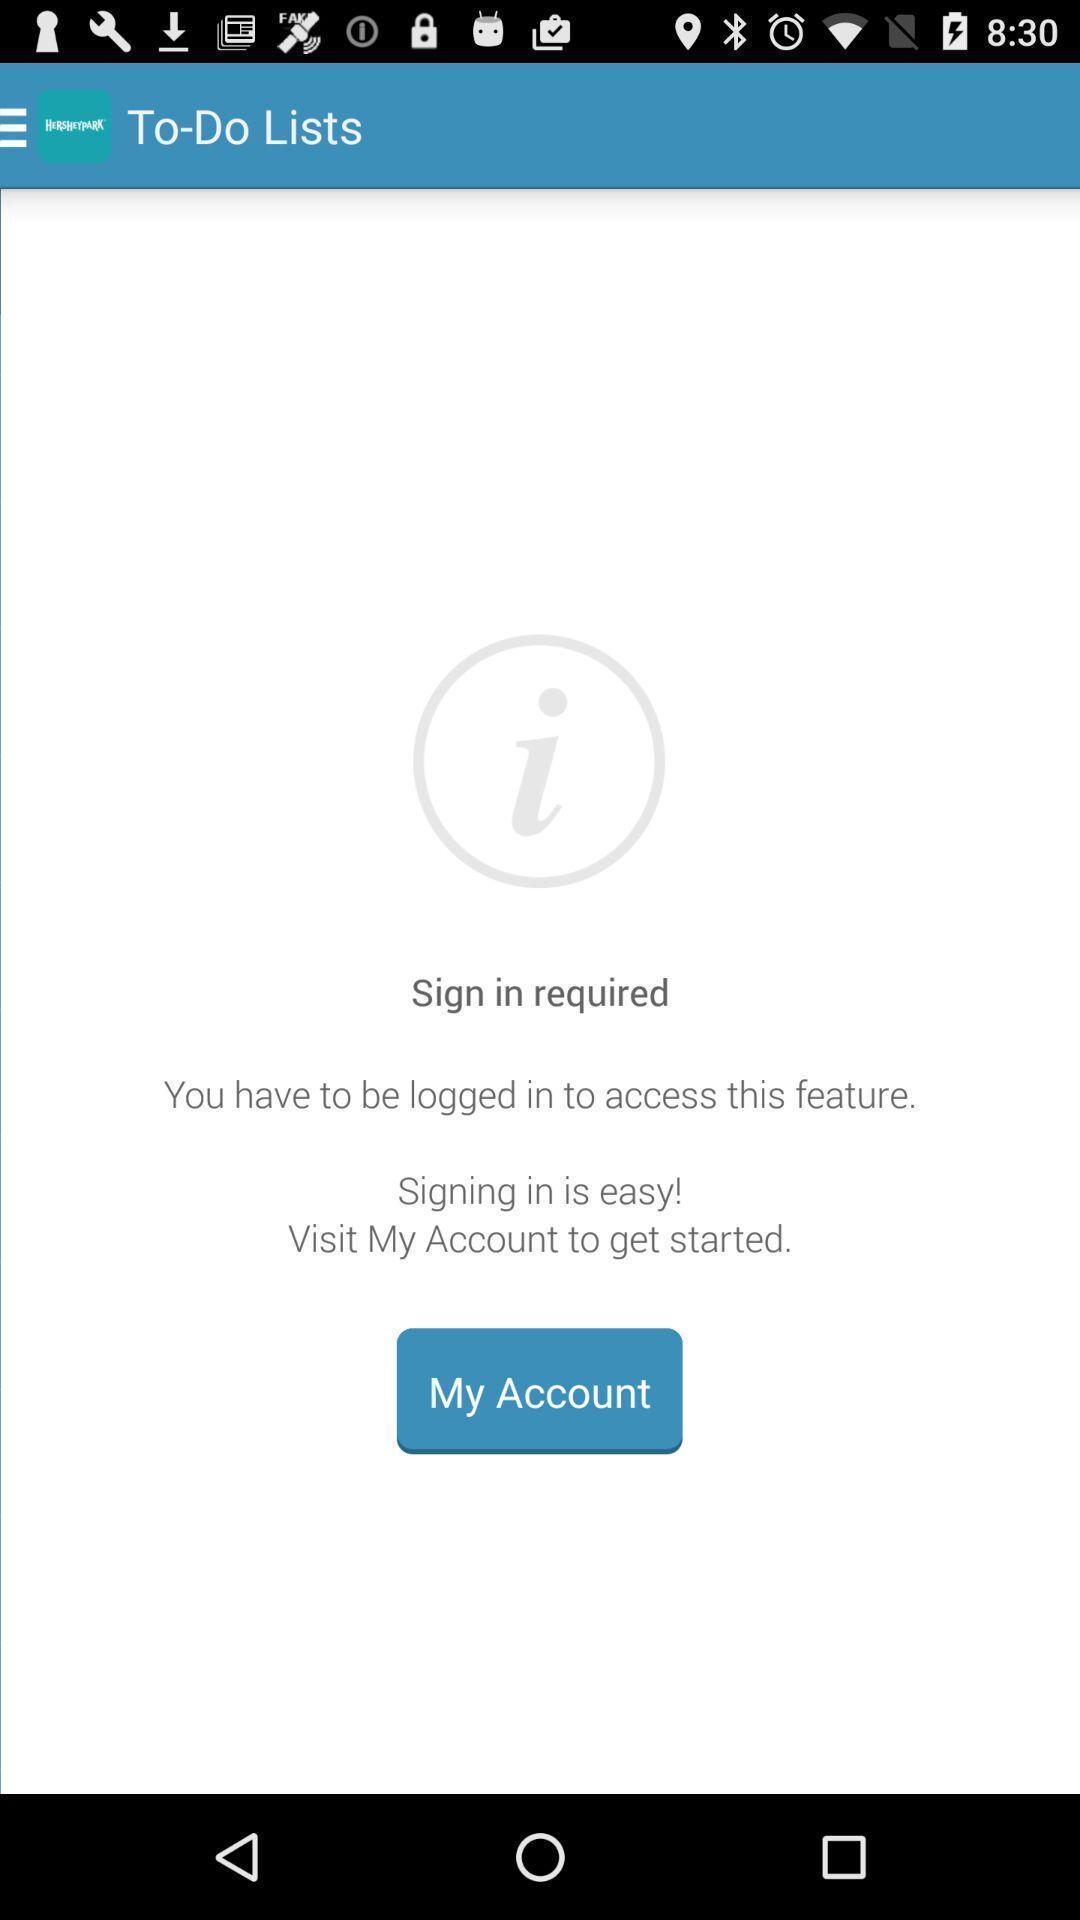Please provide a description for this image. Sign in status displaying in application. 